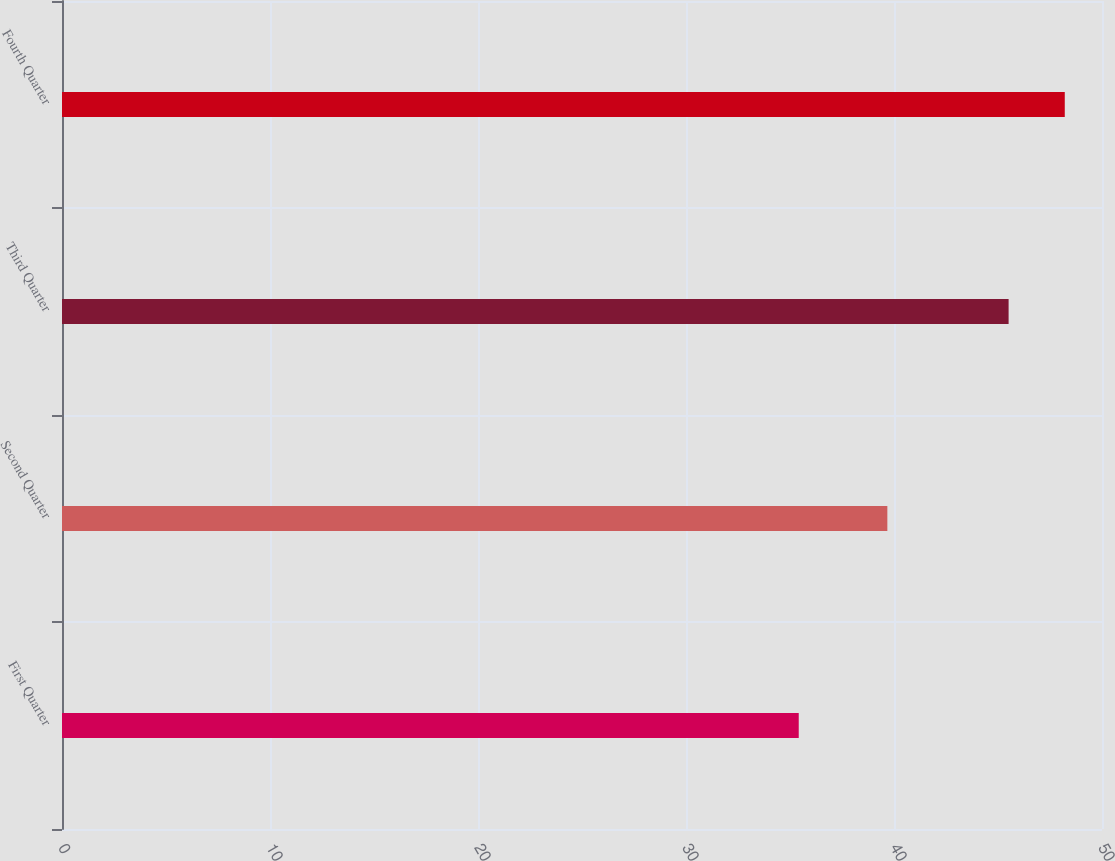<chart> <loc_0><loc_0><loc_500><loc_500><bar_chart><fcel>First Quarter<fcel>Second Quarter<fcel>Third Quarter<fcel>Fourth Quarter<nl><fcel>35.42<fcel>39.68<fcel>45.51<fcel>48.21<nl></chart> 